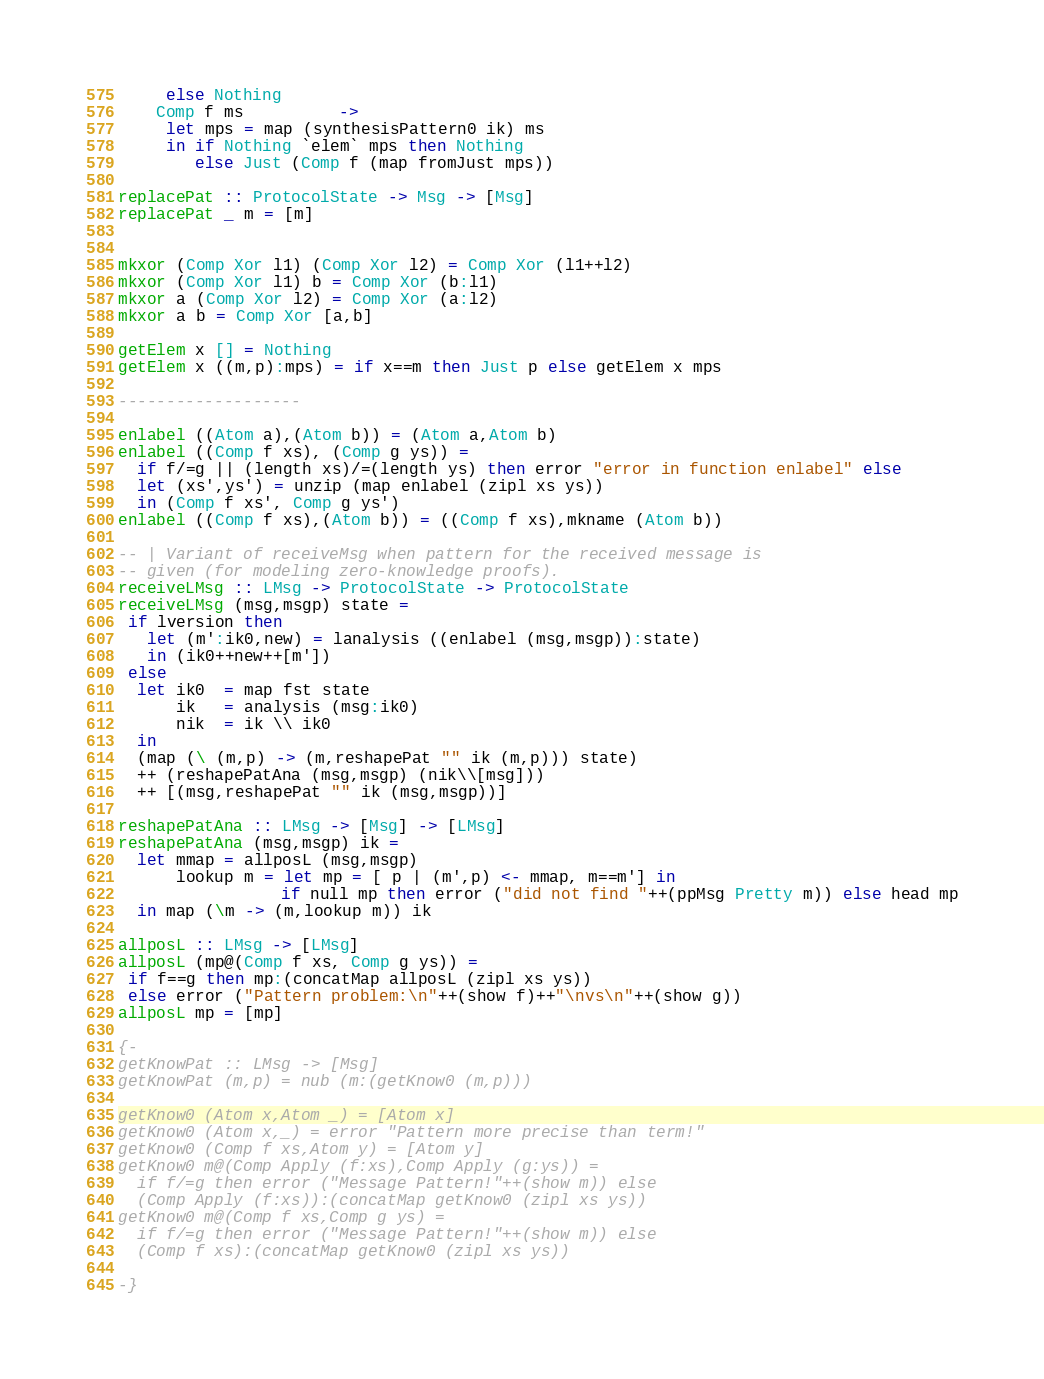<code> <loc_0><loc_0><loc_500><loc_500><_Haskell_>     else Nothing
    Comp f ms          -> 
     let mps = map (synthesisPattern0 ik) ms
     in if Nothing `elem` mps then Nothing
        else Just (Comp f (map fromJust mps))

replacePat :: ProtocolState -> Msg -> [Msg]
replacePat _ m = [m]


mkxor (Comp Xor l1) (Comp Xor l2) = Comp Xor (l1++l2)
mkxor (Comp Xor l1) b = Comp Xor (b:l1)
mkxor a (Comp Xor l2) = Comp Xor (a:l2)
mkxor a b = Comp Xor [a,b]

getElem x [] = Nothing
getElem x ((m,p):mps) = if x==m then Just p else getElem x mps

-------------------

enlabel ((Atom a),(Atom b)) = (Atom a,Atom b)
enlabel ((Comp f xs), (Comp g ys)) = 
  if f/=g || (length xs)/=(length ys) then error "error in function enlabel" else
  let (xs',ys') = unzip (map enlabel (zipl xs ys))
  in (Comp f xs', Comp g ys')
enlabel ((Comp f xs),(Atom b)) = ((Comp f xs),mkname (Atom b))

-- | Variant of receiveMsg when pattern for the received message is
-- given (for modeling zero-knowledge proofs).
receiveLMsg :: LMsg -> ProtocolState -> ProtocolState
receiveLMsg (msg,msgp) state =
 if lversion then
   let (m':ik0,new) = lanalysis ((enlabel (msg,msgp)):state)
   in (ik0++new++[m'])
 else 
  let ik0  = map fst state
      ik   = analysis (msg:ik0)
      nik  = ik \\ ik0
  in 
  (map (\ (m,p) -> (m,reshapePat "" ik (m,p))) state)
  ++ (reshapePatAna (msg,msgp) (nik\\[msg]))
  ++ [(msg,reshapePat "" ik (msg,msgp))]

reshapePatAna :: LMsg -> [Msg] -> [LMsg]
reshapePatAna (msg,msgp) ik =
  let mmap = allposL (msg,msgp) 
      lookup m = let mp = [ p | (m',p) <- mmap, m==m'] in 
      	       	 if null mp then error ("did not find "++(ppMsg Pretty m)) else head mp
  in map (\m -> (m,lookup m)) ik

allposL :: LMsg -> [LMsg]
allposL (mp@(Comp f xs, Comp g ys)) = 
 if f==g then mp:(concatMap allposL (zipl xs ys))
 else error ("Pattern problem:\n"++(show f)++"\nvs\n"++(show g))
allposL mp = [mp]

{-
getKnowPat :: LMsg -> [Msg]
getKnowPat (m,p) = nub (m:(getKnow0 (m,p)))

getKnow0 (Atom x,Atom _) = [Atom x]
getKnow0 (Atom x,_) = error "Pattern more precise than term!"
getKnow0 (Comp f xs,Atom y) = [Atom y] 
getKnow0 m@(Comp Apply (f:xs),Comp Apply (g:ys)) = 
  if f/=g then error ("Message Pattern!"++(show m)) else
  (Comp Apply (f:xs)):(concatMap getKnow0 (zipl xs ys))
getKnow0 m@(Comp f xs,Comp g ys) = 
  if f/=g then error ("Message Pattern!"++(show m)) else
  (Comp f xs):(concatMap getKnow0 (zipl xs ys))

-}</code> 